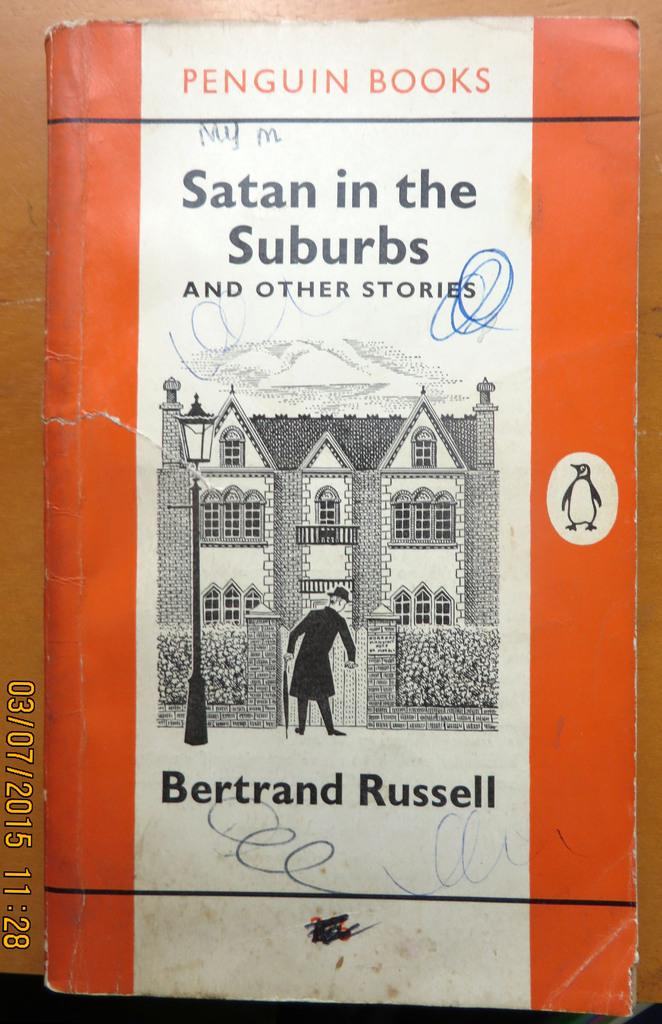<image>
Describe the image concisely. A Penguin Book is titled Satan in the Suburbs. 